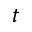<formula> <loc_0><loc_0><loc_500><loc_500>t</formula> 